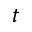<formula> <loc_0><loc_0><loc_500><loc_500>t</formula> 